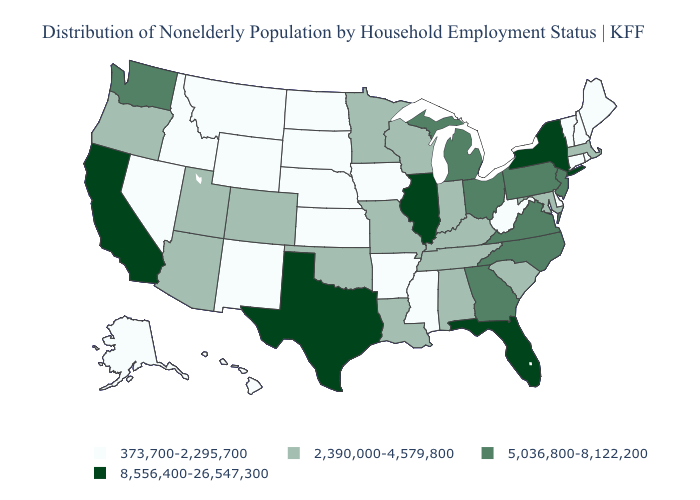Which states have the lowest value in the USA?
Be succinct. Alaska, Arkansas, Connecticut, Delaware, Hawaii, Idaho, Iowa, Kansas, Maine, Mississippi, Montana, Nebraska, Nevada, New Hampshire, New Mexico, North Dakota, Rhode Island, South Dakota, Vermont, West Virginia, Wyoming. Does Montana have a higher value than Kansas?
Concise answer only. No. Does Maryland have the lowest value in the USA?
Give a very brief answer. No. Which states hav the highest value in the Northeast?
Answer briefly. New York. Name the states that have a value in the range 8,556,400-26,547,300?
Quick response, please. California, Florida, Illinois, New York, Texas. What is the highest value in the USA?
Give a very brief answer. 8,556,400-26,547,300. What is the value of Ohio?
Quick response, please. 5,036,800-8,122,200. Does Texas have a higher value than California?
Quick response, please. No. What is the highest value in the West ?
Concise answer only. 8,556,400-26,547,300. What is the value of South Carolina?
Be succinct. 2,390,000-4,579,800. Which states have the lowest value in the South?
Give a very brief answer. Arkansas, Delaware, Mississippi, West Virginia. Which states have the highest value in the USA?
Answer briefly. California, Florida, Illinois, New York, Texas. How many symbols are there in the legend?
Keep it brief. 4. Which states hav the highest value in the Northeast?
Answer briefly. New York. What is the lowest value in the USA?
Keep it brief. 373,700-2,295,700. 